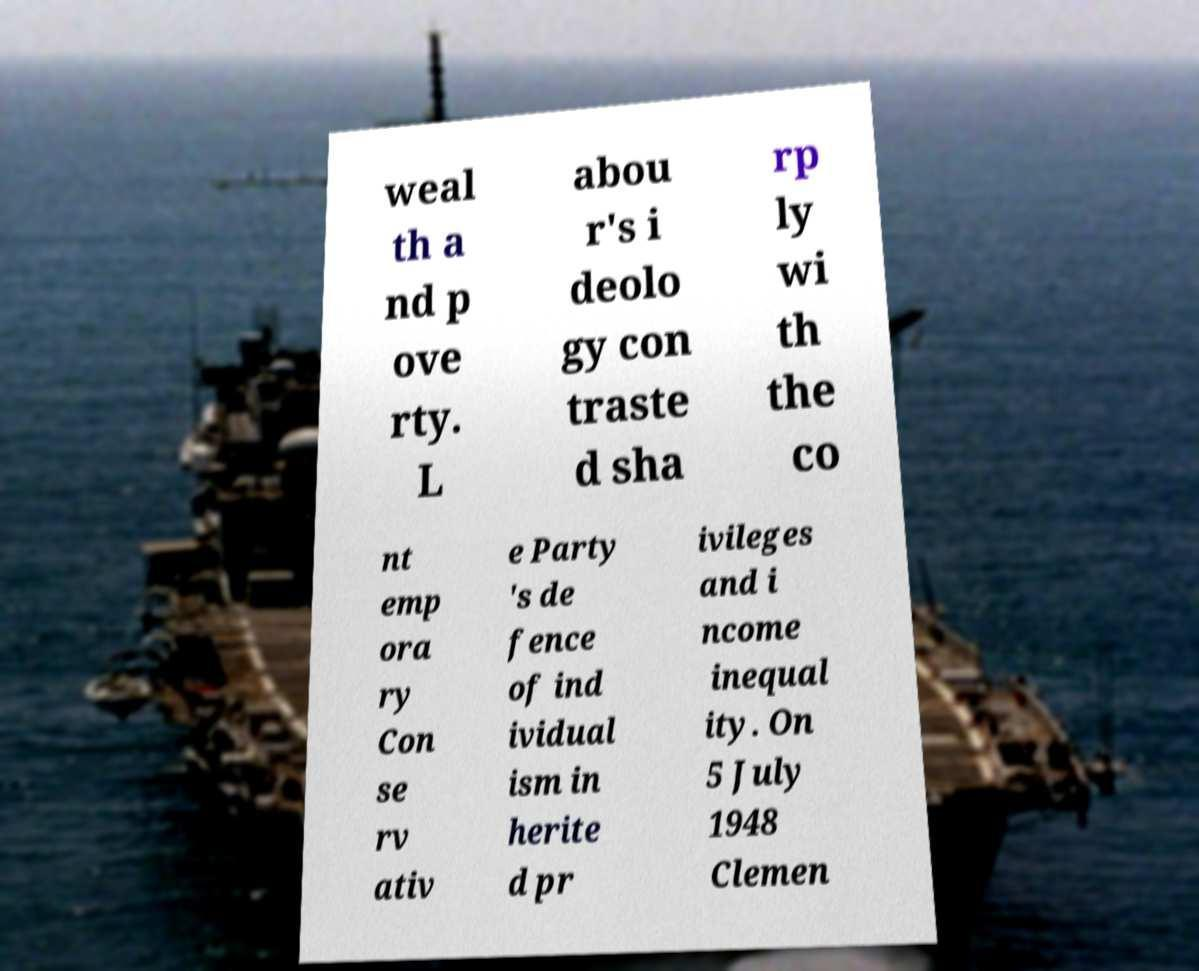I need the written content from this picture converted into text. Can you do that? weal th a nd p ove rty. L abou r's i deolo gy con traste d sha rp ly wi th the co nt emp ora ry Con se rv ativ e Party 's de fence of ind ividual ism in herite d pr ivileges and i ncome inequal ity. On 5 July 1948 Clemen 